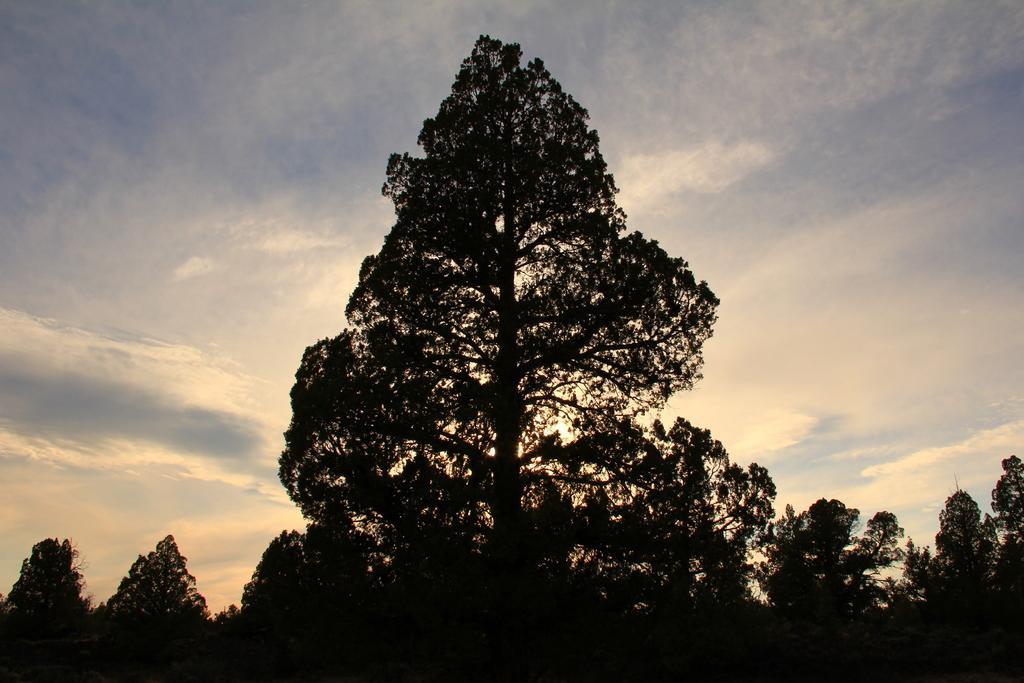What type of natural environment is depicted in the image? The image features many trees, indicating a forest or wooded area. What can be seen in the background of the image? The sky is visible in the background of the image. What type of guitar is being played in the image? There is no guitar present in the image; it features trees and the sky. What type of print can be seen on the iron in the image? There is no iron or print present in the image; it features trees and the sky. 